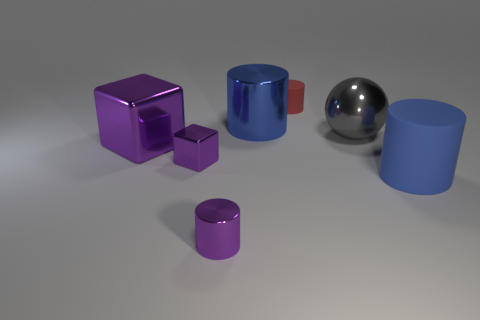Subtract all purple cylinders. Subtract all blue balls. How many cylinders are left? 3 Add 3 large cylinders. How many objects exist? 10 Subtract all balls. How many objects are left? 6 Subtract 0 gray cylinders. How many objects are left? 7 Subtract all brown rubber things. Subtract all tiny shiny blocks. How many objects are left? 6 Add 7 blue metal cylinders. How many blue metal cylinders are left? 8 Add 2 small red cylinders. How many small red cylinders exist? 3 